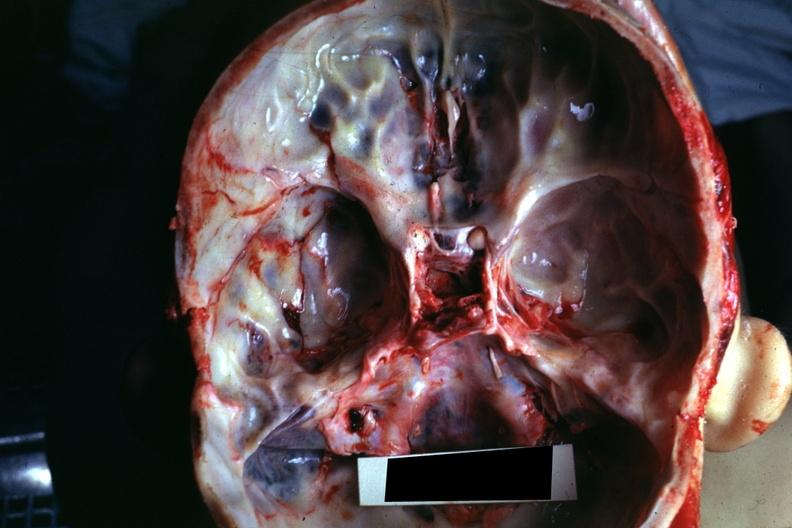s bone, calvarium present?
Answer the question using a single word or phrase. Yes 